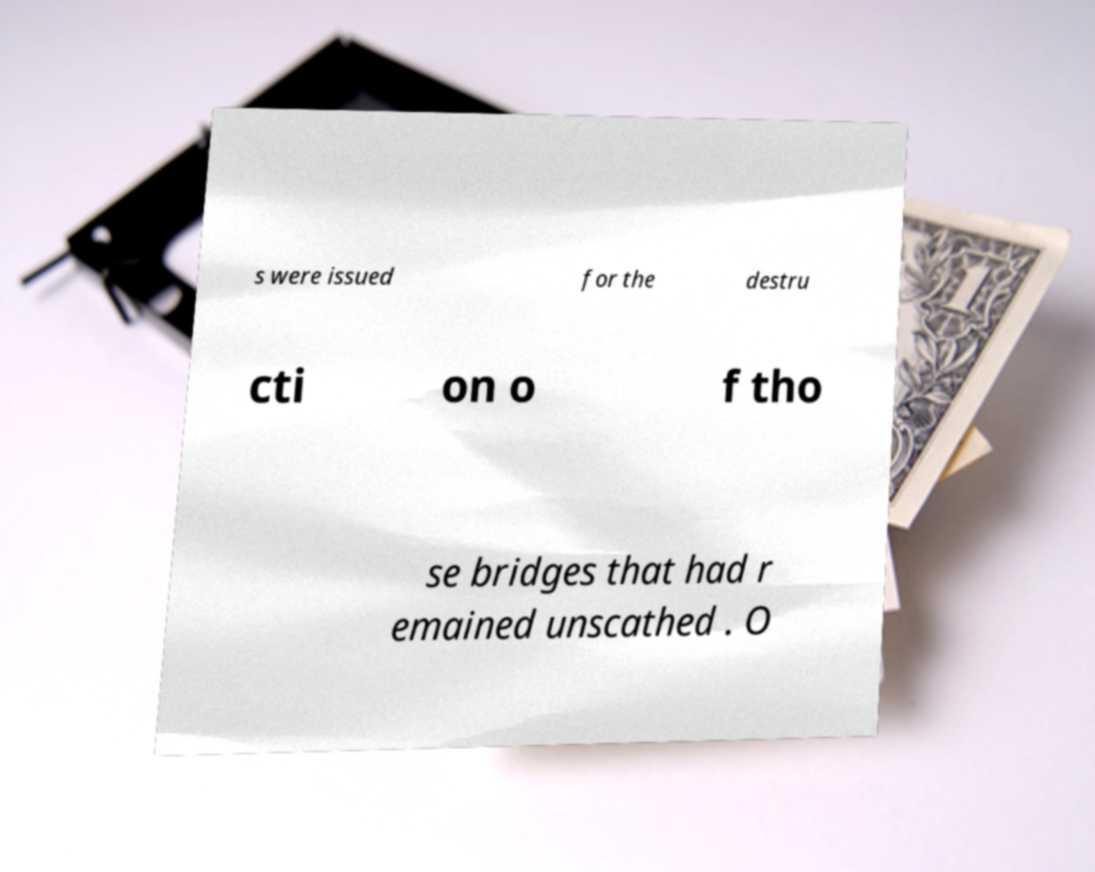Please identify and transcribe the text found in this image. s were issued for the destru cti on o f tho se bridges that had r emained unscathed . O 